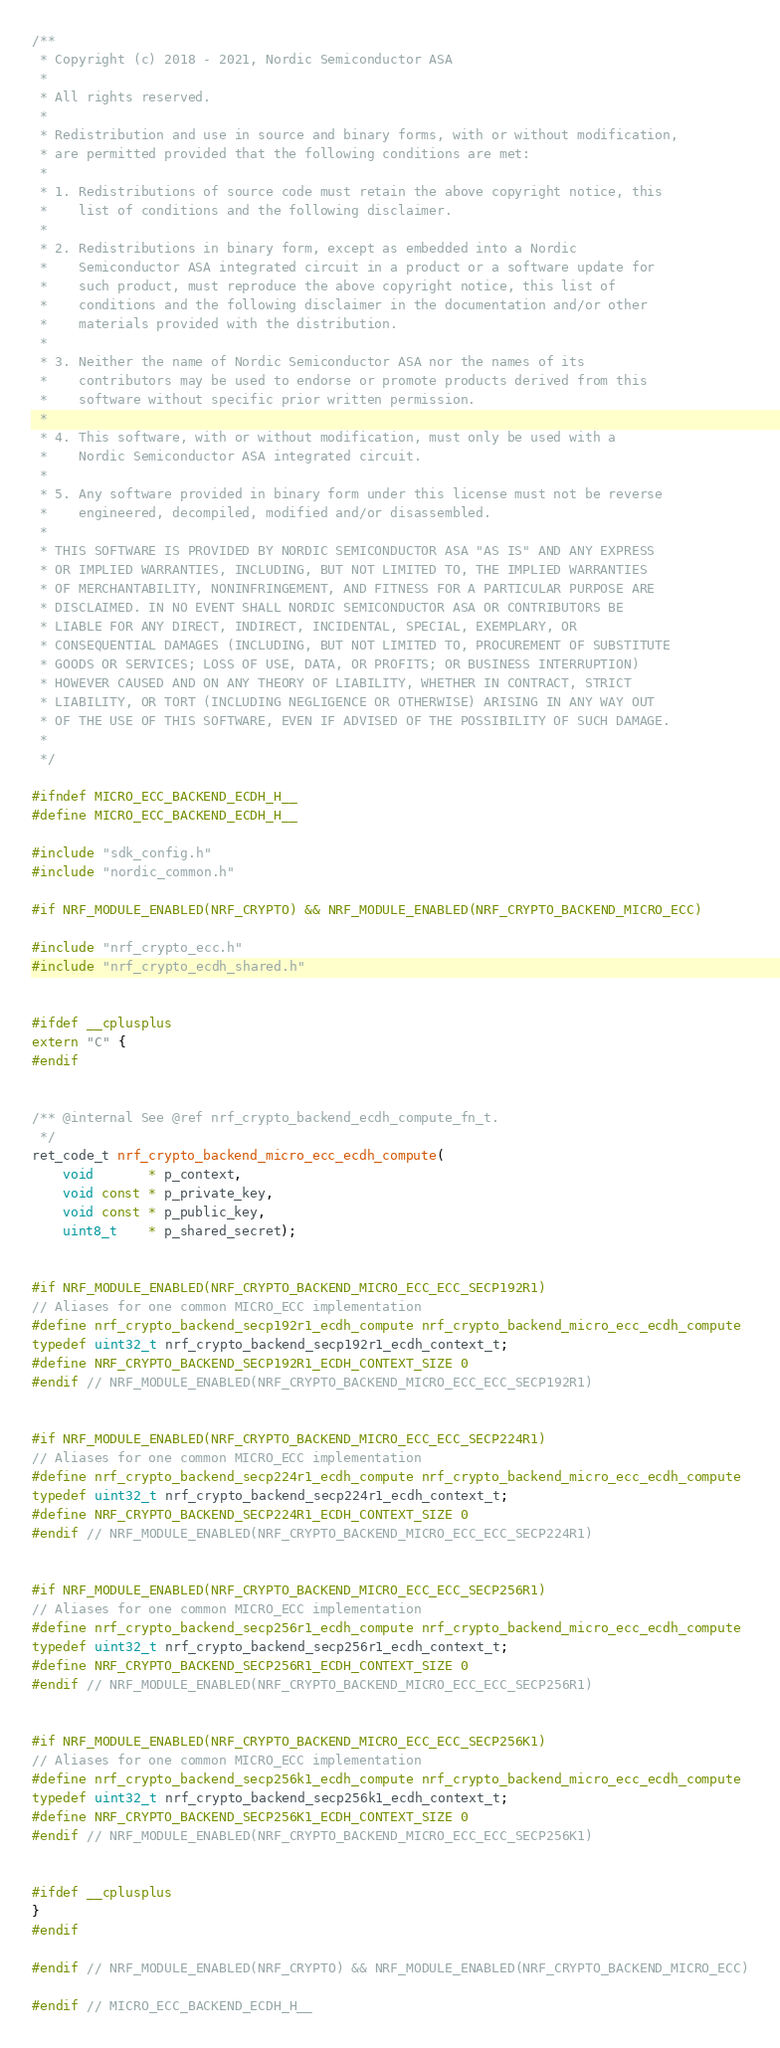Convert code to text. <code><loc_0><loc_0><loc_500><loc_500><_C_>/**
 * Copyright (c) 2018 - 2021, Nordic Semiconductor ASA
 *
 * All rights reserved.
 *
 * Redistribution and use in source and binary forms, with or without modification,
 * are permitted provided that the following conditions are met:
 *
 * 1. Redistributions of source code must retain the above copyright notice, this
 *    list of conditions and the following disclaimer.
 *
 * 2. Redistributions in binary form, except as embedded into a Nordic
 *    Semiconductor ASA integrated circuit in a product or a software update for
 *    such product, must reproduce the above copyright notice, this list of
 *    conditions and the following disclaimer in the documentation and/or other
 *    materials provided with the distribution.
 *
 * 3. Neither the name of Nordic Semiconductor ASA nor the names of its
 *    contributors may be used to endorse or promote products derived from this
 *    software without specific prior written permission.
 *
 * 4. This software, with or without modification, must only be used with a
 *    Nordic Semiconductor ASA integrated circuit.
 *
 * 5. Any software provided in binary form under this license must not be reverse
 *    engineered, decompiled, modified and/or disassembled.
 *
 * THIS SOFTWARE IS PROVIDED BY NORDIC SEMICONDUCTOR ASA "AS IS" AND ANY EXPRESS
 * OR IMPLIED WARRANTIES, INCLUDING, BUT NOT LIMITED TO, THE IMPLIED WARRANTIES
 * OF MERCHANTABILITY, NONINFRINGEMENT, AND FITNESS FOR A PARTICULAR PURPOSE ARE
 * DISCLAIMED. IN NO EVENT SHALL NORDIC SEMICONDUCTOR ASA OR CONTRIBUTORS BE
 * LIABLE FOR ANY DIRECT, INDIRECT, INCIDENTAL, SPECIAL, EXEMPLARY, OR
 * CONSEQUENTIAL DAMAGES (INCLUDING, BUT NOT LIMITED TO, PROCUREMENT OF SUBSTITUTE
 * GOODS OR SERVICES; LOSS OF USE, DATA, OR PROFITS; OR BUSINESS INTERRUPTION)
 * HOWEVER CAUSED AND ON ANY THEORY OF LIABILITY, WHETHER IN CONTRACT, STRICT
 * LIABILITY, OR TORT (INCLUDING NEGLIGENCE OR OTHERWISE) ARISING IN ANY WAY OUT
 * OF THE USE OF THIS SOFTWARE, EVEN IF ADVISED OF THE POSSIBILITY OF SUCH DAMAGE.
 *
 */

#ifndef MICRO_ECC_BACKEND_ECDH_H__
#define MICRO_ECC_BACKEND_ECDH_H__

#include "sdk_config.h"
#include "nordic_common.h"

#if NRF_MODULE_ENABLED(NRF_CRYPTO) && NRF_MODULE_ENABLED(NRF_CRYPTO_BACKEND_MICRO_ECC)

#include "nrf_crypto_ecc.h"
#include "nrf_crypto_ecdh_shared.h"


#ifdef __cplusplus
extern "C" {
#endif


/** @internal See @ref nrf_crypto_backend_ecdh_compute_fn_t.
 */
ret_code_t nrf_crypto_backend_micro_ecc_ecdh_compute(
    void       * p_context,
    void const * p_private_key,
    void const * p_public_key,
    uint8_t    * p_shared_secret);


#if NRF_MODULE_ENABLED(NRF_CRYPTO_BACKEND_MICRO_ECC_ECC_SECP192R1)
// Aliases for one common MICRO_ECC implementation
#define nrf_crypto_backend_secp192r1_ecdh_compute nrf_crypto_backend_micro_ecc_ecdh_compute
typedef uint32_t nrf_crypto_backend_secp192r1_ecdh_context_t;
#define NRF_CRYPTO_BACKEND_SECP192R1_ECDH_CONTEXT_SIZE 0
#endif // NRF_MODULE_ENABLED(NRF_CRYPTO_BACKEND_MICRO_ECC_ECC_SECP192R1)


#if NRF_MODULE_ENABLED(NRF_CRYPTO_BACKEND_MICRO_ECC_ECC_SECP224R1)
// Aliases for one common MICRO_ECC implementation
#define nrf_crypto_backend_secp224r1_ecdh_compute nrf_crypto_backend_micro_ecc_ecdh_compute
typedef uint32_t nrf_crypto_backend_secp224r1_ecdh_context_t;
#define NRF_CRYPTO_BACKEND_SECP224R1_ECDH_CONTEXT_SIZE 0
#endif // NRF_MODULE_ENABLED(NRF_CRYPTO_BACKEND_MICRO_ECC_ECC_SECP224R1)


#if NRF_MODULE_ENABLED(NRF_CRYPTO_BACKEND_MICRO_ECC_ECC_SECP256R1)
// Aliases for one common MICRO_ECC implementation
#define nrf_crypto_backend_secp256r1_ecdh_compute nrf_crypto_backend_micro_ecc_ecdh_compute
typedef uint32_t nrf_crypto_backend_secp256r1_ecdh_context_t;
#define NRF_CRYPTO_BACKEND_SECP256R1_ECDH_CONTEXT_SIZE 0
#endif // NRF_MODULE_ENABLED(NRF_CRYPTO_BACKEND_MICRO_ECC_ECC_SECP256R1)


#if NRF_MODULE_ENABLED(NRF_CRYPTO_BACKEND_MICRO_ECC_ECC_SECP256K1)
// Aliases for one common MICRO_ECC implementation
#define nrf_crypto_backend_secp256k1_ecdh_compute nrf_crypto_backend_micro_ecc_ecdh_compute
typedef uint32_t nrf_crypto_backend_secp256k1_ecdh_context_t;
#define NRF_CRYPTO_BACKEND_SECP256K1_ECDH_CONTEXT_SIZE 0
#endif // NRF_MODULE_ENABLED(NRF_CRYPTO_BACKEND_MICRO_ECC_ECC_SECP256K1)


#ifdef __cplusplus
}
#endif

#endif // NRF_MODULE_ENABLED(NRF_CRYPTO) && NRF_MODULE_ENABLED(NRF_CRYPTO_BACKEND_MICRO_ECC)

#endif // MICRO_ECC_BACKEND_ECDH_H__
</code> 